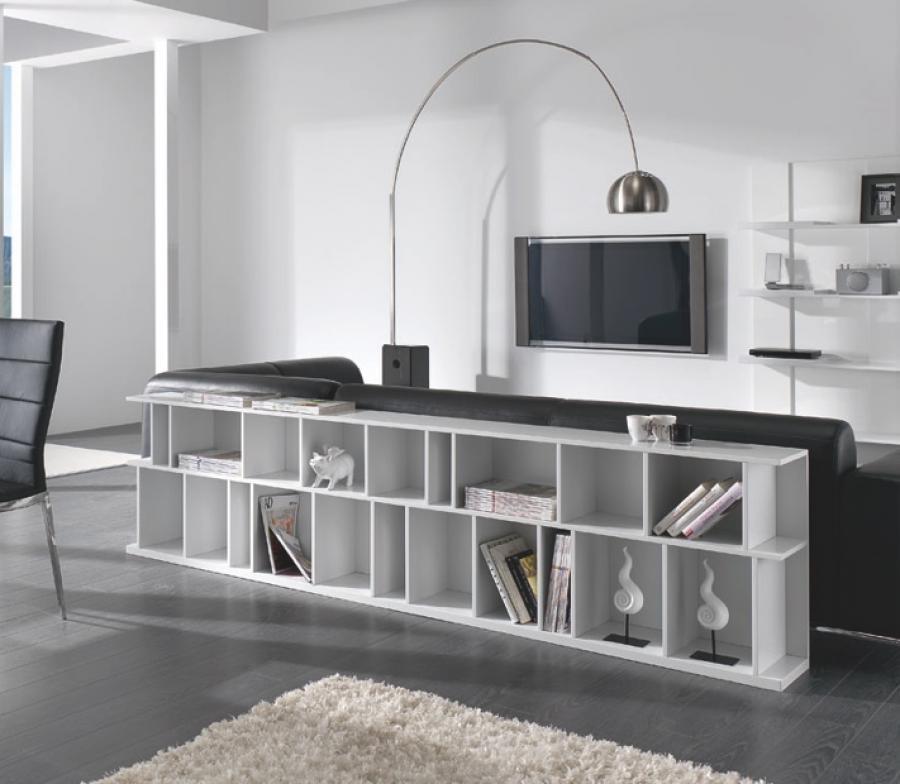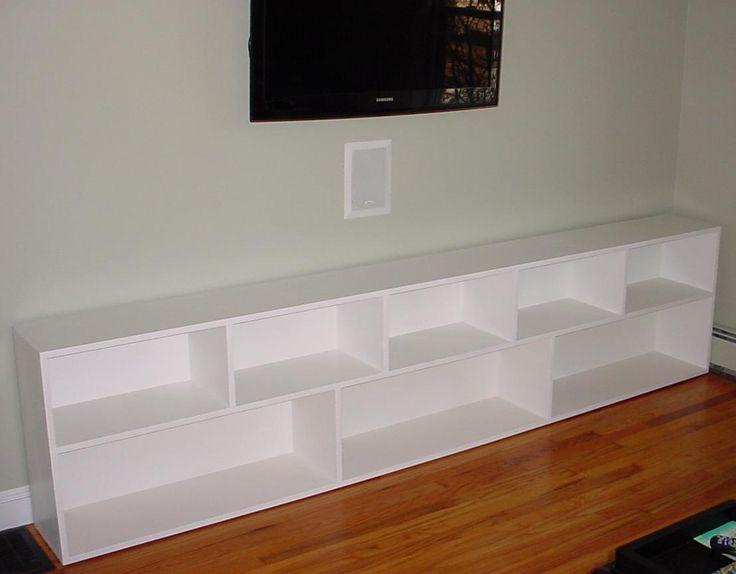The first image is the image on the left, the second image is the image on the right. Analyze the images presented: Is the assertion "There is something on the top and inside of a horizontal bookshelf unit, in one image." valid? Answer yes or no. Yes. 